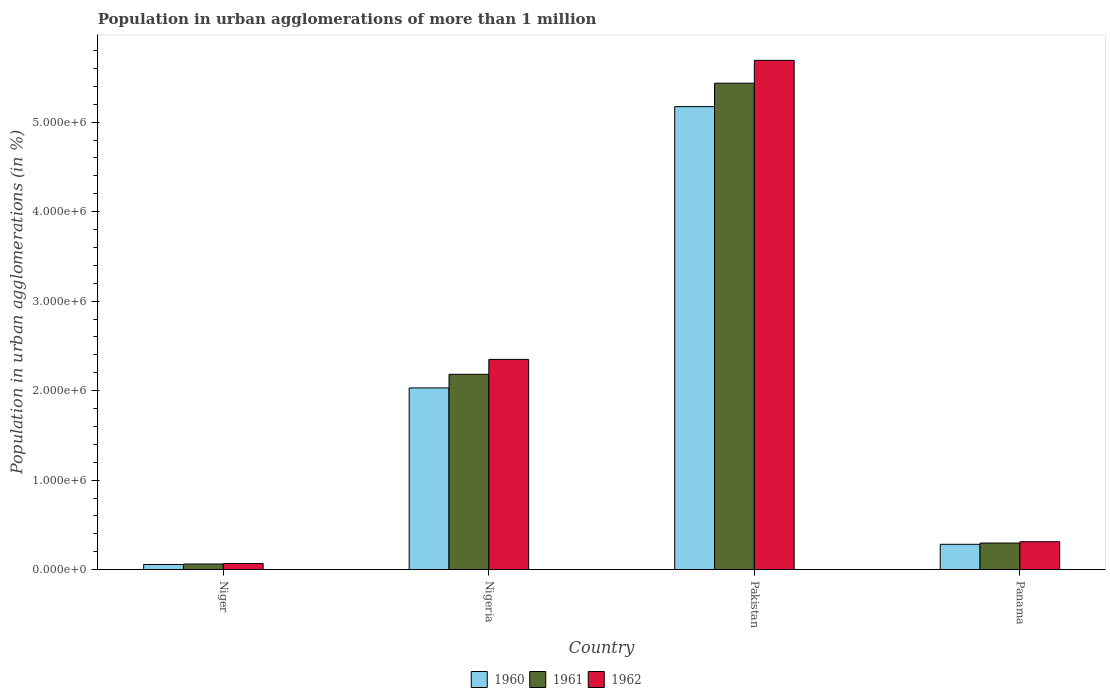Are the number of bars per tick equal to the number of legend labels?
Offer a very short reply. Yes. Are the number of bars on each tick of the X-axis equal?
Provide a succinct answer. Yes. What is the label of the 3rd group of bars from the left?
Make the answer very short. Pakistan. In how many cases, is the number of bars for a given country not equal to the number of legend labels?
Your answer should be very brief. 0. What is the population in urban agglomerations in 1960 in Pakistan?
Your answer should be very brief. 5.17e+06. Across all countries, what is the maximum population in urban agglomerations in 1962?
Offer a very short reply. 5.69e+06. Across all countries, what is the minimum population in urban agglomerations in 1962?
Provide a short and direct response. 6.83e+04. In which country was the population in urban agglomerations in 1960 maximum?
Provide a short and direct response. Pakistan. In which country was the population in urban agglomerations in 1961 minimum?
Ensure brevity in your answer.  Niger. What is the total population in urban agglomerations in 1960 in the graph?
Give a very brief answer. 7.55e+06. What is the difference between the population in urban agglomerations in 1960 in Niger and that in Panama?
Provide a succinct answer. -2.25e+05. What is the difference between the population in urban agglomerations in 1962 in Nigeria and the population in urban agglomerations in 1961 in Niger?
Offer a terse response. 2.29e+06. What is the average population in urban agglomerations in 1960 per country?
Give a very brief answer. 1.89e+06. What is the difference between the population in urban agglomerations of/in 1961 and population in urban agglomerations of/in 1960 in Panama?
Your response must be concise. 1.42e+04. What is the ratio of the population in urban agglomerations in 1960 in Nigeria to that in Panama?
Make the answer very short. 7.18. Is the population in urban agglomerations in 1962 in Pakistan less than that in Panama?
Your answer should be compact. No. What is the difference between the highest and the second highest population in urban agglomerations in 1962?
Provide a short and direct response. 2.04e+06. What is the difference between the highest and the lowest population in urban agglomerations in 1962?
Your answer should be very brief. 5.62e+06. In how many countries, is the population in urban agglomerations in 1961 greater than the average population in urban agglomerations in 1961 taken over all countries?
Offer a terse response. 2. Are all the bars in the graph horizontal?
Your answer should be very brief. No. Does the graph contain any zero values?
Provide a succinct answer. No. Does the graph contain grids?
Keep it short and to the point. No. How many legend labels are there?
Your response must be concise. 3. How are the legend labels stacked?
Your answer should be compact. Horizontal. What is the title of the graph?
Keep it short and to the point. Population in urban agglomerations of more than 1 million. Does "2015" appear as one of the legend labels in the graph?
Offer a very short reply. No. What is the label or title of the X-axis?
Offer a very short reply. Country. What is the label or title of the Y-axis?
Provide a short and direct response. Population in urban agglomerations (in %). What is the Population in urban agglomerations (in %) of 1960 in Niger?
Make the answer very short. 5.75e+04. What is the Population in urban agglomerations (in %) in 1961 in Niger?
Your answer should be very brief. 6.27e+04. What is the Population in urban agglomerations (in %) in 1962 in Niger?
Your answer should be very brief. 6.83e+04. What is the Population in urban agglomerations (in %) of 1960 in Nigeria?
Your answer should be compact. 2.03e+06. What is the Population in urban agglomerations (in %) in 1961 in Nigeria?
Keep it short and to the point. 2.18e+06. What is the Population in urban agglomerations (in %) of 1962 in Nigeria?
Give a very brief answer. 2.35e+06. What is the Population in urban agglomerations (in %) of 1960 in Pakistan?
Your answer should be compact. 5.17e+06. What is the Population in urban agglomerations (in %) of 1961 in Pakistan?
Provide a short and direct response. 5.44e+06. What is the Population in urban agglomerations (in %) of 1962 in Pakistan?
Offer a very short reply. 5.69e+06. What is the Population in urban agglomerations (in %) of 1960 in Panama?
Make the answer very short. 2.83e+05. What is the Population in urban agglomerations (in %) of 1961 in Panama?
Your answer should be compact. 2.97e+05. What is the Population in urban agglomerations (in %) in 1962 in Panama?
Provide a short and direct response. 3.12e+05. Across all countries, what is the maximum Population in urban agglomerations (in %) in 1960?
Provide a succinct answer. 5.17e+06. Across all countries, what is the maximum Population in urban agglomerations (in %) in 1961?
Your answer should be compact. 5.44e+06. Across all countries, what is the maximum Population in urban agglomerations (in %) in 1962?
Your answer should be compact. 5.69e+06. Across all countries, what is the minimum Population in urban agglomerations (in %) of 1960?
Your response must be concise. 5.75e+04. Across all countries, what is the minimum Population in urban agglomerations (in %) of 1961?
Offer a very short reply. 6.27e+04. Across all countries, what is the minimum Population in urban agglomerations (in %) in 1962?
Offer a terse response. 6.83e+04. What is the total Population in urban agglomerations (in %) of 1960 in the graph?
Your response must be concise. 7.55e+06. What is the total Population in urban agglomerations (in %) in 1961 in the graph?
Offer a terse response. 7.98e+06. What is the total Population in urban agglomerations (in %) of 1962 in the graph?
Ensure brevity in your answer.  8.42e+06. What is the difference between the Population in urban agglomerations (in %) in 1960 in Niger and that in Nigeria?
Keep it short and to the point. -1.97e+06. What is the difference between the Population in urban agglomerations (in %) of 1961 in Niger and that in Nigeria?
Give a very brief answer. -2.12e+06. What is the difference between the Population in urban agglomerations (in %) in 1962 in Niger and that in Nigeria?
Ensure brevity in your answer.  -2.28e+06. What is the difference between the Population in urban agglomerations (in %) in 1960 in Niger and that in Pakistan?
Ensure brevity in your answer.  -5.12e+06. What is the difference between the Population in urban agglomerations (in %) in 1961 in Niger and that in Pakistan?
Ensure brevity in your answer.  -5.37e+06. What is the difference between the Population in urban agglomerations (in %) of 1962 in Niger and that in Pakistan?
Keep it short and to the point. -5.62e+06. What is the difference between the Population in urban agglomerations (in %) in 1960 in Niger and that in Panama?
Ensure brevity in your answer.  -2.25e+05. What is the difference between the Population in urban agglomerations (in %) of 1961 in Niger and that in Panama?
Give a very brief answer. -2.34e+05. What is the difference between the Population in urban agglomerations (in %) of 1962 in Niger and that in Panama?
Your answer should be compact. -2.43e+05. What is the difference between the Population in urban agglomerations (in %) in 1960 in Nigeria and that in Pakistan?
Provide a short and direct response. -3.14e+06. What is the difference between the Population in urban agglomerations (in %) in 1961 in Nigeria and that in Pakistan?
Give a very brief answer. -3.25e+06. What is the difference between the Population in urban agglomerations (in %) in 1962 in Nigeria and that in Pakistan?
Provide a short and direct response. -3.34e+06. What is the difference between the Population in urban agglomerations (in %) of 1960 in Nigeria and that in Panama?
Keep it short and to the point. 1.75e+06. What is the difference between the Population in urban agglomerations (in %) in 1961 in Nigeria and that in Panama?
Provide a short and direct response. 1.89e+06. What is the difference between the Population in urban agglomerations (in %) of 1962 in Nigeria and that in Panama?
Offer a very short reply. 2.04e+06. What is the difference between the Population in urban agglomerations (in %) of 1960 in Pakistan and that in Panama?
Offer a terse response. 4.89e+06. What is the difference between the Population in urban agglomerations (in %) of 1961 in Pakistan and that in Panama?
Offer a terse response. 5.14e+06. What is the difference between the Population in urban agglomerations (in %) in 1962 in Pakistan and that in Panama?
Your response must be concise. 5.38e+06. What is the difference between the Population in urban agglomerations (in %) in 1960 in Niger and the Population in urban agglomerations (in %) in 1961 in Nigeria?
Give a very brief answer. -2.13e+06. What is the difference between the Population in urban agglomerations (in %) in 1960 in Niger and the Population in urban agglomerations (in %) in 1962 in Nigeria?
Your answer should be compact. -2.29e+06. What is the difference between the Population in urban agglomerations (in %) of 1961 in Niger and the Population in urban agglomerations (in %) of 1962 in Nigeria?
Your response must be concise. -2.29e+06. What is the difference between the Population in urban agglomerations (in %) of 1960 in Niger and the Population in urban agglomerations (in %) of 1961 in Pakistan?
Give a very brief answer. -5.38e+06. What is the difference between the Population in urban agglomerations (in %) of 1960 in Niger and the Population in urban agglomerations (in %) of 1962 in Pakistan?
Provide a succinct answer. -5.63e+06. What is the difference between the Population in urban agglomerations (in %) of 1961 in Niger and the Population in urban agglomerations (in %) of 1962 in Pakistan?
Your response must be concise. -5.63e+06. What is the difference between the Population in urban agglomerations (in %) of 1960 in Niger and the Population in urban agglomerations (in %) of 1961 in Panama?
Your answer should be compact. -2.40e+05. What is the difference between the Population in urban agglomerations (in %) of 1960 in Niger and the Population in urban agglomerations (in %) of 1962 in Panama?
Ensure brevity in your answer.  -2.54e+05. What is the difference between the Population in urban agglomerations (in %) of 1961 in Niger and the Population in urban agglomerations (in %) of 1962 in Panama?
Offer a very short reply. -2.49e+05. What is the difference between the Population in urban agglomerations (in %) in 1960 in Nigeria and the Population in urban agglomerations (in %) in 1961 in Pakistan?
Your answer should be compact. -3.41e+06. What is the difference between the Population in urban agglomerations (in %) of 1960 in Nigeria and the Population in urban agglomerations (in %) of 1962 in Pakistan?
Offer a terse response. -3.66e+06. What is the difference between the Population in urban agglomerations (in %) in 1961 in Nigeria and the Population in urban agglomerations (in %) in 1962 in Pakistan?
Ensure brevity in your answer.  -3.51e+06. What is the difference between the Population in urban agglomerations (in %) in 1960 in Nigeria and the Population in urban agglomerations (in %) in 1961 in Panama?
Your answer should be very brief. 1.73e+06. What is the difference between the Population in urban agglomerations (in %) of 1960 in Nigeria and the Population in urban agglomerations (in %) of 1962 in Panama?
Give a very brief answer. 1.72e+06. What is the difference between the Population in urban agglomerations (in %) of 1961 in Nigeria and the Population in urban agglomerations (in %) of 1962 in Panama?
Provide a short and direct response. 1.87e+06. What is the difference between the Population in urban agglomerations (in %) of 1960 in Pakistan and the Population in urban agglomerations (in %) of 1961 in Panama?
Your response must be concise. 4.88e+06. What is the difference between the Population in urban agglomerations (in %) in 1960 in Pakistan and the Population in urban agglomerations (in %) in 1962 in Panama?
Your answer should be compact. 4.86e+06. What is the difference between the Population in urban agglomerations (in %) of 1961 in Pakistan and the Population in urban agglomerations (in %) of 1962 in Panama?
Your answer should be compact. 5.12e+06. What is the average Population in urban agglomerations (in %) in 1960 per country?
Your response must be concise. 1.89e+06. What is the average Population in urban agglomerations (in %) of 1961 per country?
Your response must be concise. 1.99e+06. What is the average Population in urban agglomerations (in %) of 1962 per country?
Keep it short and to the point. 2.11e+06. What is the difference between the Population in urban agglomerations (in %) in 1960 and Population in urban agglomerations (in %) in 1961 in Niger?
Your response must be concise. -5156. What is the difference between the Population in urban agglomerations (in %) of 1960 and Population in urban agglomerations (in %) of 1962 in Niger?
Your answer should be very brief. -1.08e+04. What is the difference between the Population in urban agglomerations (in %) of 1961 and Population in urban agglomerations (in %) of 1962 in Niger?
Provide a short and direct response. -5625. What is the difference between the Population in urban agglomerations (in %) of 1960 and Population in urban agglomerations (in %) of 1961 in Nigeria?
Offer a terse response. -1.52e+05. What is the difference between the Population in urban agglomerations (in %) in 1960 and Population in urban agglomerations (in %) in 1962 in Nigeria?
Your answer should be compact. -3.19e+05. What is the difference between the Population in urban agglomerations (in %) in 1961 and Population in urban agglomerations (in %) in 1962 in Nigeria?
Your response must be concise. -1.66e+05. What is the difference between the Population in urban agglomerations (in %) in 1960 and Population in urban agglomerations (in %) in 1961 in Pakistan?
Keep it short and to the point. -2.61e+05. What is the difference between the Population in urban agglomerations (in %) of 1960 and Population in urban agglomerations (in %) of 1962 in Pakistan?
Your answer should be very brief. -5.17e+05. What is the difference between the Population in urban agglomerations (in %) of 1961 and Population in urban agglomerations (in %) of 1962 in Pakistan?
Keep it short and to the point. -2.56e+05. What is the difference between the Population in urban agglomerations (in %) of 1960 and Population in urban agglomerations (in %) of 1961 in Panama?
Your answer should be compact. -1.42e+04. What is the difference between the Population in urban agglomerations (in %) of 1960 and Population in urban agglomerations (in %) of 1962 in Panama?
Keep it short and to the point. -2.87e+04. What is the difference between the Population in urban agglomerations (in %) of 1961 and Population in urban agglomerations (in %) of 1962 in Panama?
Your answer should be compact. -1.45e+04. What is the ratio of the Population in urban agglomerations (in %) in 1960 in Niger to that in Nigeria?
Provide a short and direct response. 0.03. What is the ratio of the Population in urban agglomerations (in %) of 1961 in Niger to that in Nigeria?
Your answer should be very brief. 0.03. What is the ratio of the Population in urban agglomerations (in %) of 1962 in Niger to that in Nigeria?
Make the answer very short. 0.03. What is the ratio of the Population in urban agglomerations (in %) in 1960 in Niger to that in Pakistan?
Your response must be concise. 0.01. What is the ratio of the Population in urban agglomerations (in %) of 1961 in Niger to that in Pakistan?
Ensure brevity in your answer.  0.01. What is the ratio of the Population in urban agglomerations (in %) in 1962 in Niger to that in Pakistan?
Your answer should be very brief. 0.01. What is the ratio of the Population in urban agglomerations (in %) in 1960 in Niger to that in Panama?
Ensure brevity in your answer.  0.2. What is the ratio of the Population in urban agglomerations (in %) of 1961 in Niger to that in Panama?
Give a very brief answer. 0.21. What is the ratio of the Population in urban agglomerations (in %) of 1962 in Niger to that in Panama?
Provide a succinct answer. 0.22. What is the ratio of the Population in urban agglomerations (in %) of 1960 in Nigeria to that in Pakistan?
Provide a short and direct response. 0.39. What is the ratio of the Population in urban agglomerations (in %) in 1961 in Nigeria to that in Pakistan?
Offer a terse response. 0.4. What is the ratio of the Population in urban agglomerations (in %) in 1962 in Nigeria to that in Pakistan?
Your answer should be very brief. 0.41. What is the ratio of the Population in urban agglomerations (in %) in 1960 in Nigeria to that in Panama?
Give a very brief answer. 7.18. What is the ratio of the Population in urban agglomerations (in %) in 1961 in Nigeria to that in Panama?
Your response must be concise. 7.35. What is the ratio of the Population in urban agglomerations (in %) of 1962 in Nigeria to that in Panama?
Keep it short and to the point. 7.54. What is the ratio of the Population in urban agglomerations (in %) in 1960 in Pakistan to that in Panama?
Provide a short and direct response. 18.29. What is the ratio of the Population in urban agglomerations (in %) in 1961 in Pakistan to that in Panama?
Offer a very short reply. 18.3. What is the ratio of the Population in urban agglomerations (in %) of 1962 in Pakistan to that in Panama?
Provide a succinct answer. 18.26. What is the difference between the highest and the second highest Population in urban agglomerations (in %) in 1960?
Offer a very short reply. 3.14e+06. What is the difference between the highest and the second highest Population in urban agglomerations (in %) in 1961?
Your answer should be compact. 3.25e+06. What is the difference between the highest and the second highest Population in urban agglomerations (in %) of 1962?
Your response must be concise. 3.34e+06. What is the difference between the highest and the lowest Population in urban agglomerations (in %) in 1960?
Your answer should be compact. 5.12e+06. What is the difference between the highest and the lowest Population in urban agglomerations (in %) of 1961?
Your answer should be compact. 5.37e+06. What is the difference between the highest and the lowest Population in urban agglomerations (in %) of 1962?
Your answer should be very brief. 5.62e+06. 